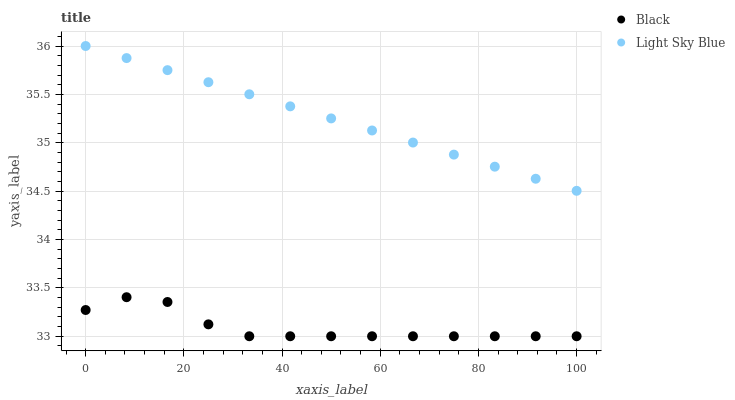Does Black have the minimum area under the curve?
Answer yes or no. Yes. Does Light Sky Blue have the maximum area under the curve?
Answer yes or no. Yes. Does Black have the maximum area under the curve?
Answer yes or no. No. Is Light Sky Blue the smoothest?
Answer yes or no. Yes. Is Black the roughest?
Answer yes or no. Yes. Is Black the smoothest?
Answer yes or no. No. Does Black have the lowest value?
Answer yes or no. Yes. Does Light Sky Blue have the highest value?
Answer yes or no. Yes. Does Black have the highest value?
Answer yes or no. No. Is Black less than Light Sky Blue?
Answer yes or no. Yes. Is Light Sky Blue greater than Black?
Answer yes or no. Yes. Does Black intersect Light Sky Blue?
Answer yes or no. No. 